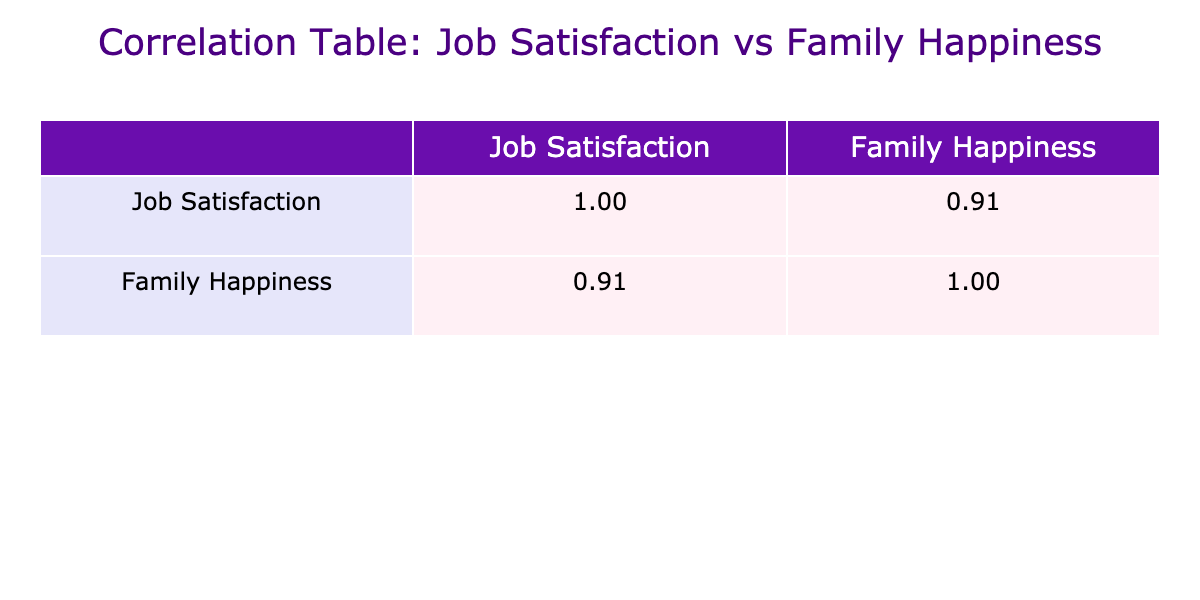What is the Job Satisfaction Score for Emily Davis? From the table, we look at Emily Davis's row and find her Job Satisfaction Score listed as 9.
Answer: 9 What is the highest Perceived Family Happiness Score in the table? We can scan the Perceived Family Happiness Score column for the highest value, which is 10, observed in Emily Davis and Sophia Lee's entries.
Answer: 10 Which employee has the lowest Job Satisfaction Score, and what is it? In scanning through the Job Satisfaction Score column, we identify Daniel Garcia with the lowest score of 3.
Answer: Daniel Garcia, 3 Is the correlation between Job Satisfaction Score and Perceived Family Happiness Score positive? By looking at the correlation values in the table, we see a positive correlation exists between the two scores.
Answer: Yes What is the average Job Satisfaction Score of all employees in the table? To find the average, we first sum all Job Satisfaction Scores: 7 + 5 + 8 + 4 + 9 + 6 + 8 + 3 + 10 + 5 + 7 + 4 + 9 + 6 + 5 = 7. The total number of employees is 15, so the average is 7/15 = 6.67.
Answer: 6.67 How many employees have a Job Satisfaction Score greater than 6? By reviewing the Job Satisfaction Score column, we count the scores above 6: Alice Johnson, Sarah Wilson, Emily Davis, Jessica Thompson, Kate Taylor, and Sophia Lee, totaling 6 employees.
Answer: 6 What is the difference between the highest and lowest Job Satisfaction Scores? The highest score, 10 (Elizabeth Miller), and the lowest score, 3 (Daniel Garcia), gives us a difference of 10 - 3 = 7.
Answer: 7 If we only consider employees with a Job Satisfaction Score of 6 or lower, what is the average Perceived Family Happiness Score for those employees? Focusing on scores 6 or lower, we find the relevant entries: Michael Smith (6), David Brown (5), John Martinez (7), Daniel Garcia (4), Chris Anderson (5), Brian Hall (3), and James King (6). Their corresponding Family Happiness Scores are 6, 5, 7, 4, 5, 3, and 6. The total is 36/7 = 5.14.
Answer: 5.14 How many employees reported both a Job Satisfaction Score and a Perceived Family Happiness Score higher than 6? Counting the employees with Job Satisfaction Scores high than 6, we look at Alice Johnson, Sarah Wilson, Emily Davis, Jessica Thompson, and Sophia Lee, which gives us 5 employees with Family Happiness Scores also higher than 6.
Answer: 5 